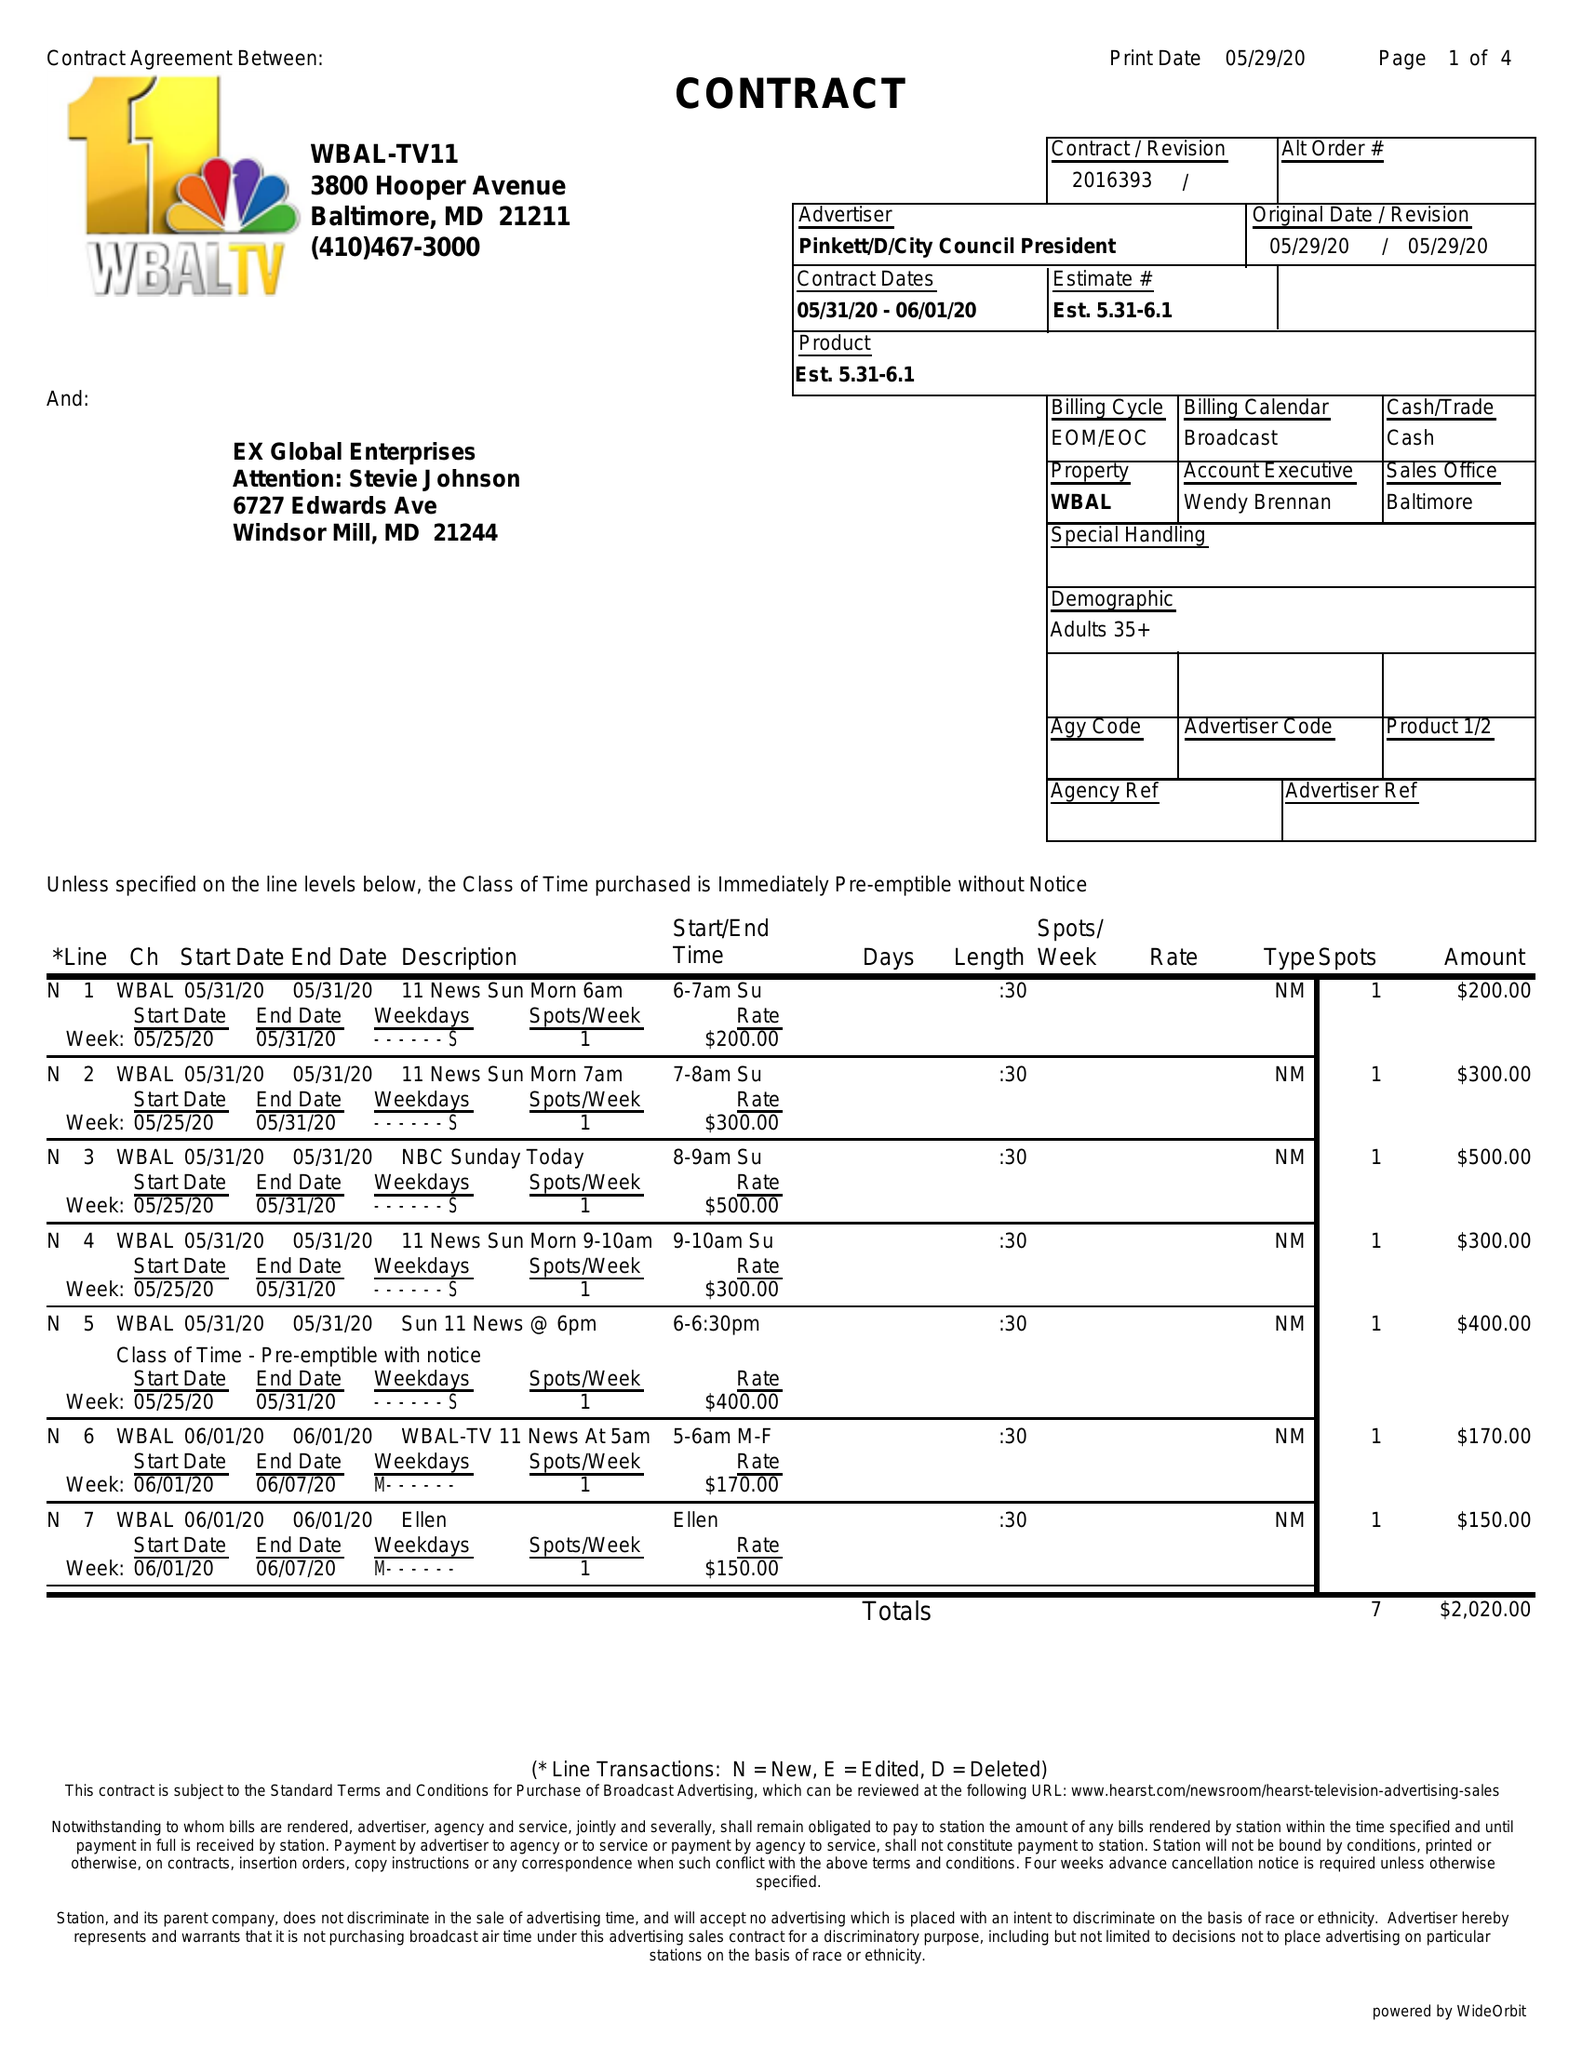What is the value for the flight_from?
Answer the question using a single word or phrase. 05/31/20 